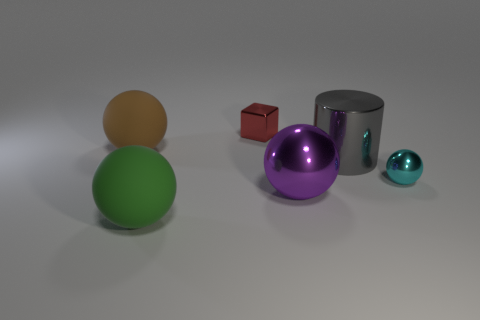Subtract 1 spheres. How many spheres are left? 3 Add 4 big gray cylinders. How many objects exist? 10 Subtract all cylinders. How many objects are left? 5 Subtract 1 gray cylinders. How many objects are left? 5 Subtract all big purple cylinders. Subtract all large gray metal cylinders. How many objects are left? 5 Add 6 cyan metallic spheres. How many cyan metallic spheres are left? 7 Add 6 small red blocks. How many small red blocks exist? 7 